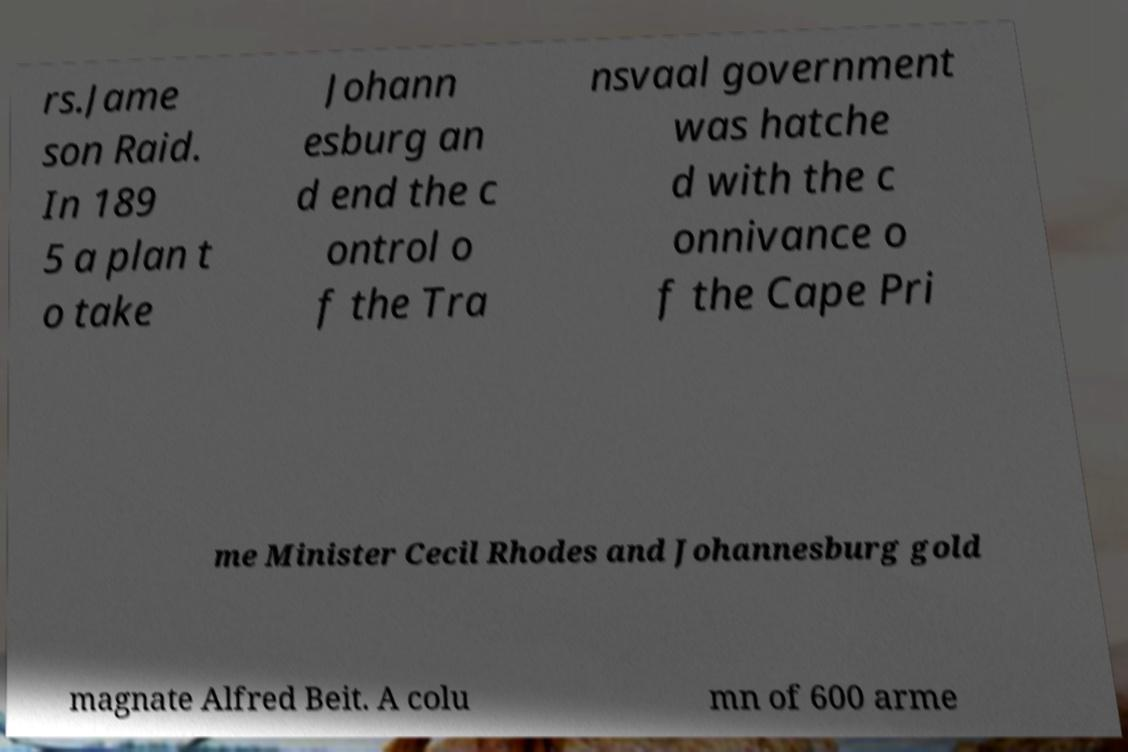Please read and relay the text visible in this image. What does it say? rs.Jame son Raid. In 189 5 a plan t o take Johann esburg an d end the c ontrol o f the Tra nsvaal government was hatche d with the c onnivance o f the Cape Pri me Minister Cecil Rhodes and Johannesburg gold magnate Alfred Beit. A colu mn of 600 arme 